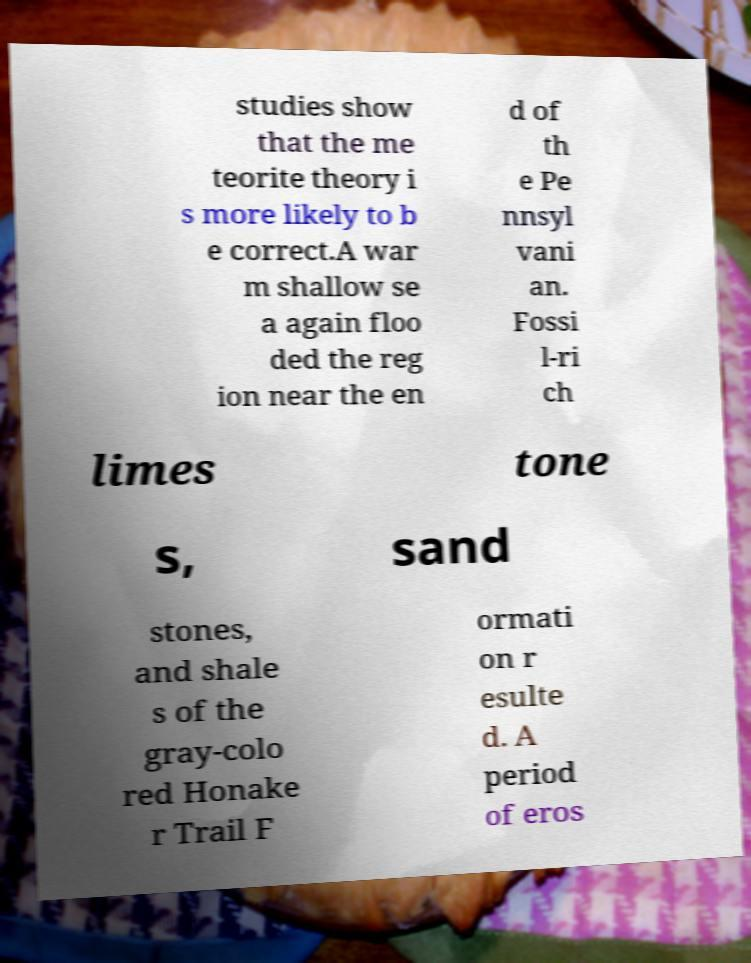Please identify and transcribe the text found in this image. studies show that the me teorite theory i s more likely to b e correct.A war m shallow se a again floo ded the reg ion near the en d of th e Pe nnsyl vani an. Fossi l-ri ch limes tone s, sand stones, and shale s of the gray-colo red Honake r Trail F ormati on r esulte d. A period of eros 